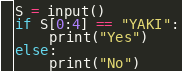<code> <loc_0><loc_0><loc_500><loc_500><_Python_>S = input()
if S[0:4] == "YAKI":
    print("Yes")
else:
    print("No")

</code> 